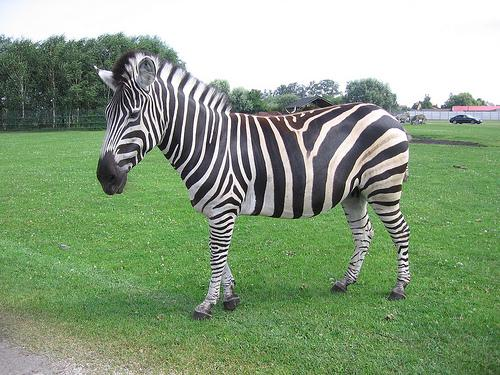Are there any vehicles in the image, and if so, describe them. Yes, there is a black car driving down the road and a moving small car. How many hooves does the main animal in the image have? The zebra has four hooves. Describe the environment surrounding the zebra in the image. The zebra is standing on short, healthy green grass with trees in the background, a large open grass area, and a path beside the grass. What type of stripes does the zebra have? The zebra has black and white stripes. List at least three objects or structures seen in the image besides the zebra. White wall barricade, sandy looking soil area, and a red roof structure in the background. Identify the most prominent animal in the image and describe its appearance. A majestic looking zebra with black and white stripes, a medium length mane, a black nose, and four hooves. What type of structure is visible in the background of the image, and what is its roof color? A building with a red roof. How many elephants are possibly sitting in the image? There are two possible sitting elephants. Describe the possible debris on the ground in the image. There is debris of some kind on the ground, possibly a pile of excrement and litter. What is the dominant color of the sky in the image? The sky is oddly bright white. Can you see the swimming unicorn in the water near the zebra? The unicorn has a golden horn and a long tail. No, it's not mentioned in the image. Identify any anomalies, if present in the image. The oddly bright white sky is an anomaly. Count the number of legs the zebra has. The zebra has four legs. Find the area described as a possible pile of excrement. X:441 Y:155 Width:44 Height:44 Point out the location of the zebra's mouth area. X:106 Y:171 Width:22 Height:22 Evaluate the overall quality of the image. The image is clear with well-defined objects. Which object has the highest height value? A majestic looking zebra with X:81 Y:40 Width:362 Height:362 What emotion does the image evoke? Neutral, as it's a natural scenery with a zebra. Analyze if the zebra is interacting with any other objects in the image. The zebra is not interacting with other objects directly. What is the condition of the grass where the zebra is standing? The grass is very short and appears healthy. What are the colors of the zebra? The zebra is white with black stripes. Are there any visible texts or writings in the image? No, there are no visible texts or writings. Locate the zebras right ear. X:135 Y:55 Width:28 Height:28 Describe the color and type of the roof found in the background. Red roof on top of a structure in the background. What type of area is the zebra standing on? Large open grass area with short, healthy green grass. Describe the main object in the image. A majestic looking zebra standing on grass with black and white stripes. Is there a car in the image? If yes, is it moving or stationary? Yes, a moving small black car on the road. State the overall sentiment conveyed by the image. Neutral sentiment, as it is a natural scenery with a zebra. Describe the attributes of the zebra's mane. The zebra has a medium length, black and white mane with mohawk hair. Identify the object with the lowest X-coordinate position. Sandy looking soil area with X:0 Y:337 Width:105 Height:105. 